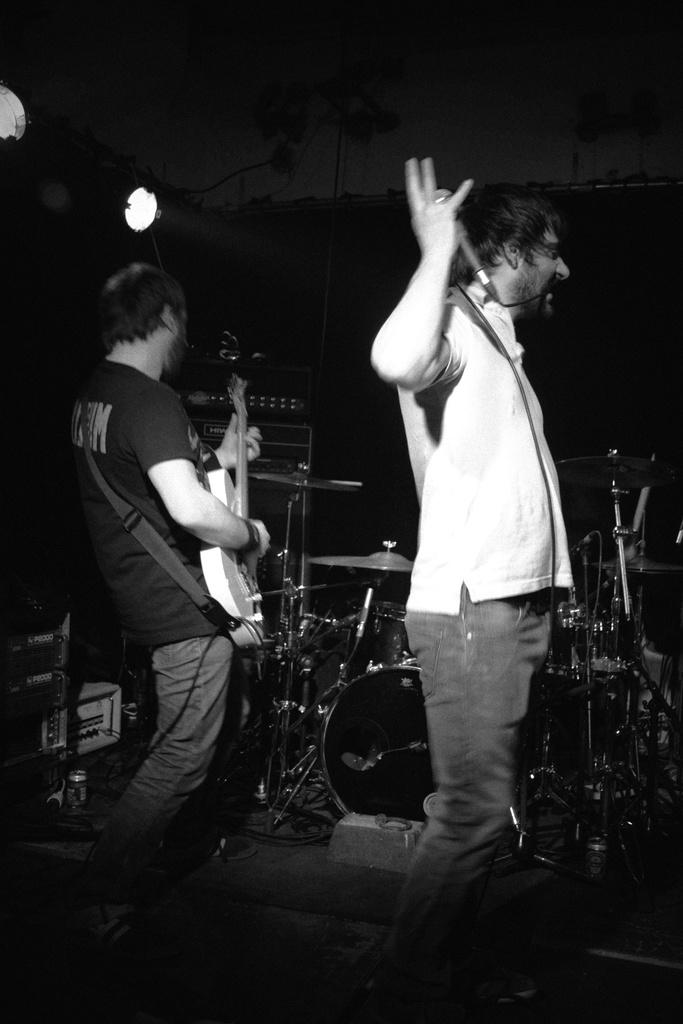How many people are in the image? There are two men in the image. What is one of the men doing in the image? One of the men is playing the guitar. What is the other man holding in his hand? The other man is holding a microphone in his hand. What type of fan is visible in the image? There is no fan present in the image. How many twigs can be seen in the image? There are no twigs visible in the image. 